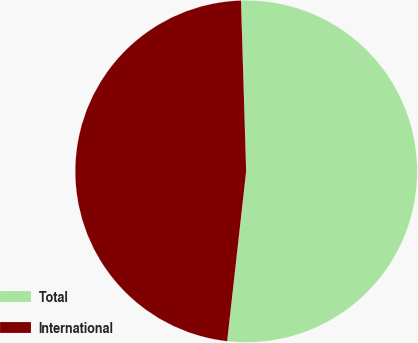Convert chart. <chart><loc_0><loc_0><loc_500><loc_500><pie_chart><fcel>Total<fcel>International<nl><fcel>52.25%<fcel>47.75%<nl></chart> 